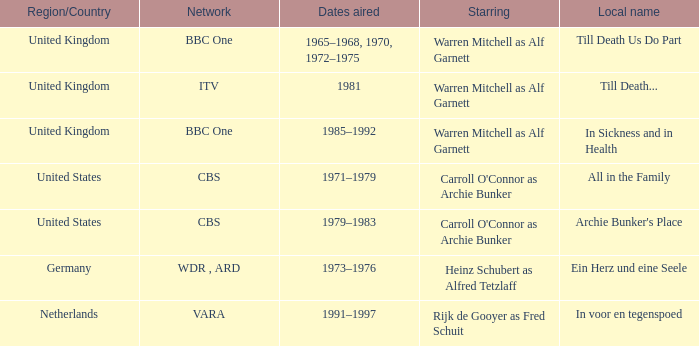Who was the star for the Vara network? Rijk de Gooyer as Fred Schuit. 